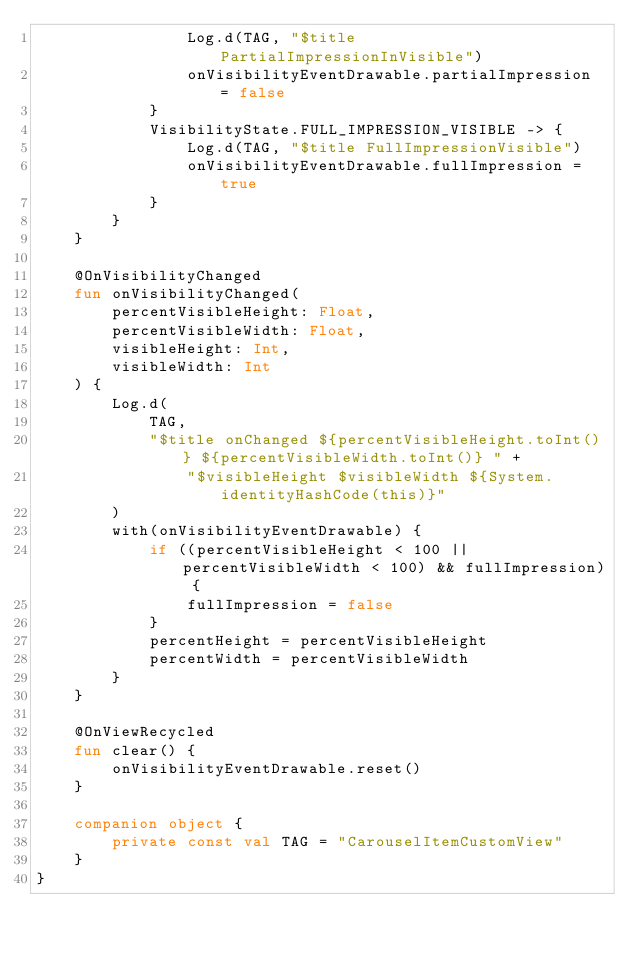<code> <loc_0><loc_0><loc_500><loc_500><_Kotlin_>                Log.d(TAG, "$title PartialImpressionInVisible")
                onVisibilityEventDrawable.partialImpression = false
            }
            VisibilityState.FULL_IMPRESSION_VISIBLE -> {
                Log.d(TAG, "$title FullImpressionVisible")
                onVisibilityEventDrawable.fullImpression = true
            }
        }
    }

    @OnVisibilityChanged
    fun onVisibilityChanged(
        percentVisibleHeight: Float,
        percentVisibleWidth: Float,
        visibleHeight: Int,
        visibleWidth: Int
    ) {
        Log.d(
            TAG,
            "$title onChanged ${percentVisibleHeight.toInt()} ${percentVisibleWidth.toInt()} " +
                "$visibleHeight $visibleWidth ${System.identityHashCode(this)}"
        )
        with(onVisibilityEventDrawable) {
            if ((percentVisibleHeight < 100 || percentVisibleWidth < 100) && fullImpression) {
                fullImpression = false
            }
            percentHeight = percentVisibleHeight
            percentWidth = percentVisibleWidth
        }
    }

    @OnViewRecycled
    fun clear() {
        onVisibilityEventDrawable.reset()
    }

    companion object {
        private const val TAG = "CarouselItemCustomView"
    }
}
</code> 